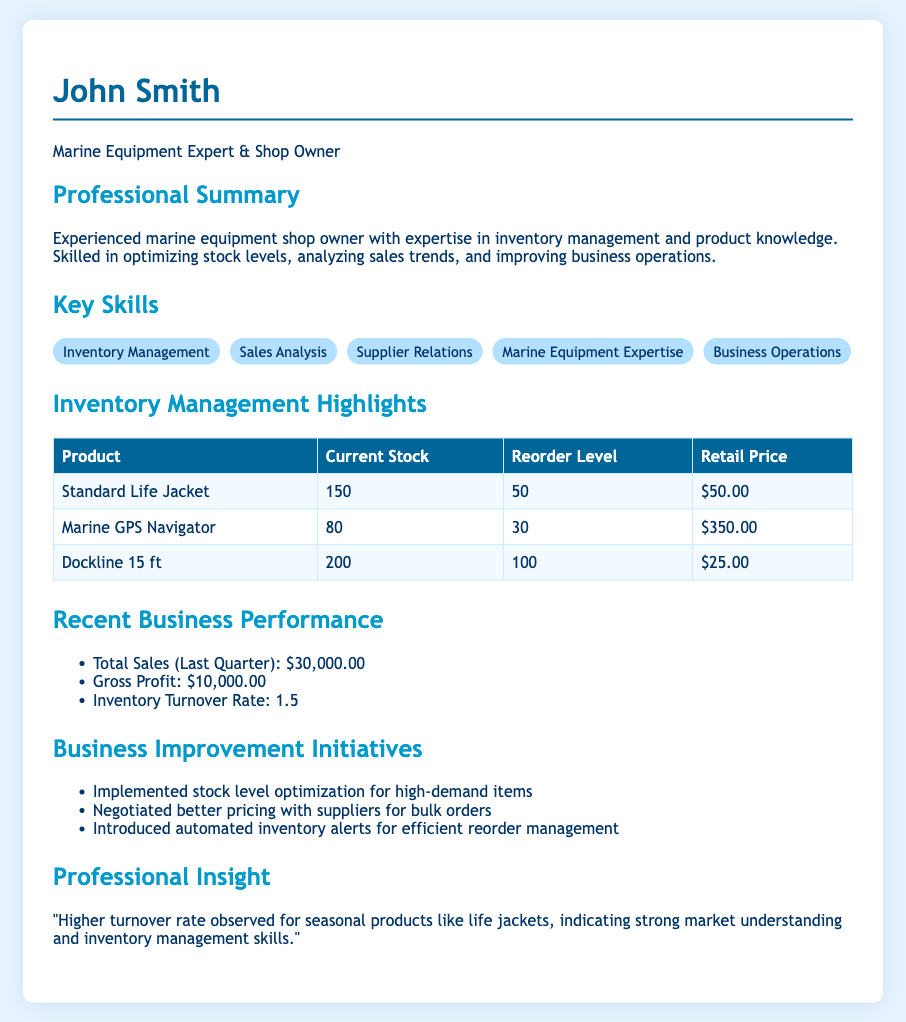What is the name of the owner? The name of the owner is mentioned at the top of the document as John Smith.
Answer: John Smith What is the total sales for the last quarter? The total sales for the last quarter is provided as a specific figure in the document.
Answer: $30,000.00 What is the current stock level of the Marine GPS Navigator? The current stock level of the Marine GPS Navigator is listed in the inventory management section.
Answer: 80 What is the inventory turnover rate? The inventory turnover rate is highlighted as part of recent business performance in the document.
Answer: 1.5 What is the retail price of a Standard Life Jacket? The retail price of the Standard Life Jacket is specified in the inventory management highlights.
Answer: $50.00 What business improvement initiative was implemented for high-demand items? One of the business improvement initiatives mentioned in the document indicates specific actions taken for high-demand items.
Answer: Stock level optimization What is listed as a recent gross profit? The gross profit is clearly presented in the recent business performance section of the document.
Answer: $10,000.00 What is the reorder level for Dockline 15 ft? The reorder level for Dockline 15 ft can be found in the inventory management highlights table.
Answer: 100 What is the purpose of the automated inventory alerts? The purpose of automated inventory alerts is described among the business improvement initiatives listed.
Answer: Efficient reorder management 